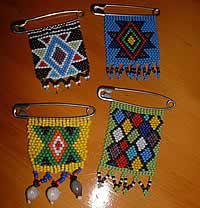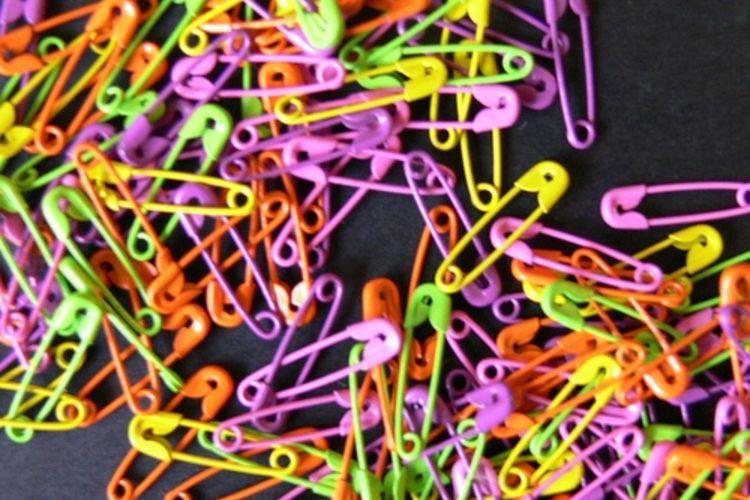The first image is the image on the left, the second image is the image on the right. For the images displayed, is the sentence "An image shows flat beaded items in geometric shapes." factually correct? Answer yes or no. Yes. 